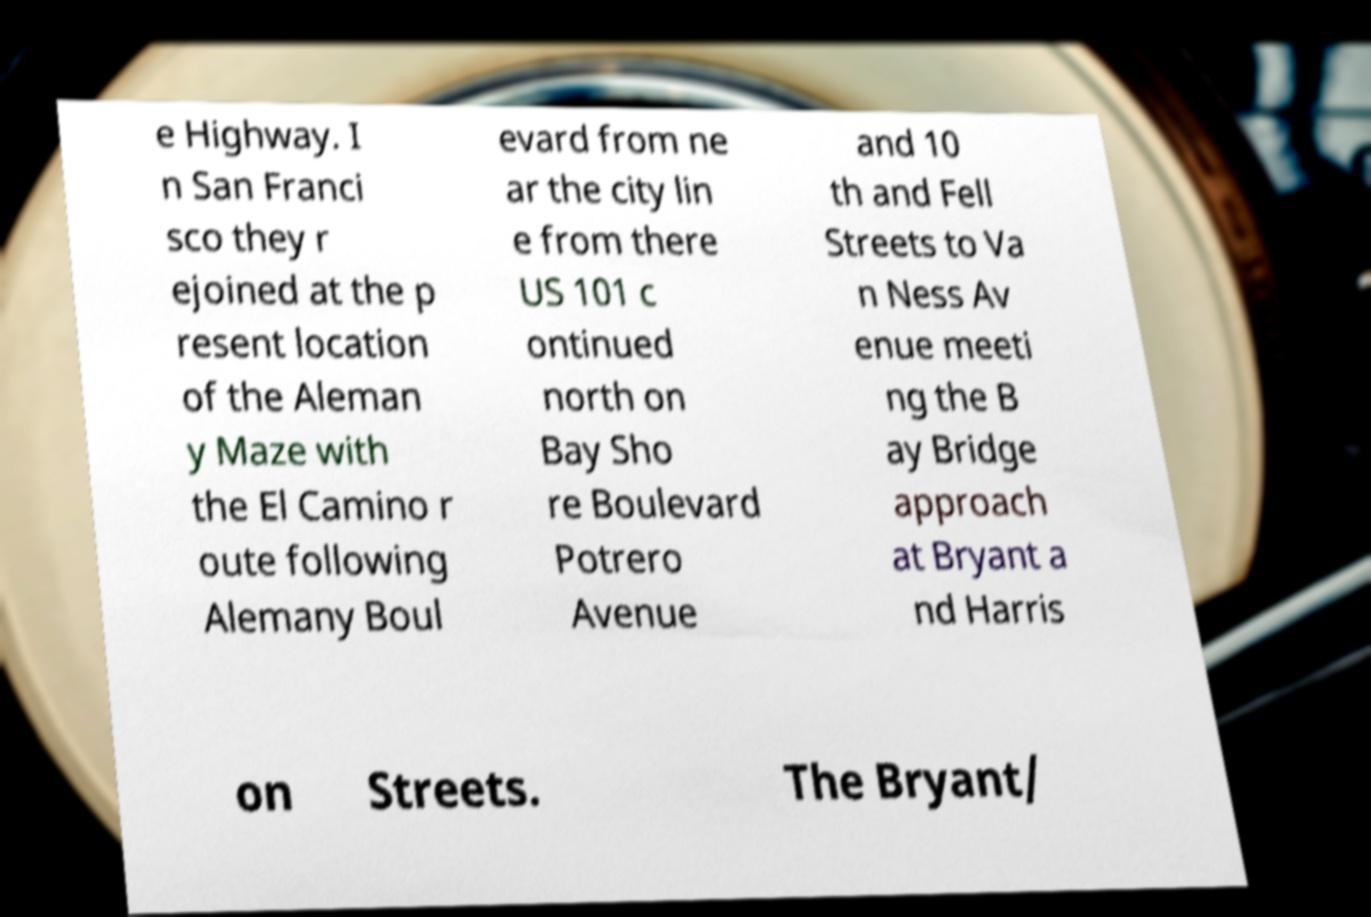Please read and relay the text visible in this image. What does it say? e Highway. I n San Franci sco they r ejoined at the p resent location of the Aleman y Maze with the El Camino r oute following Alemany Boul evard from ne ar the city lin e from there US 101 c ontinued north on Bay Sho re Boulevard Potrero Avenue and 10 th and Fell Streets to Va n Ness Av enue meeti ng the B ay Bridge approach at Bryant a nd Harris on Streets. The Bryant/ 